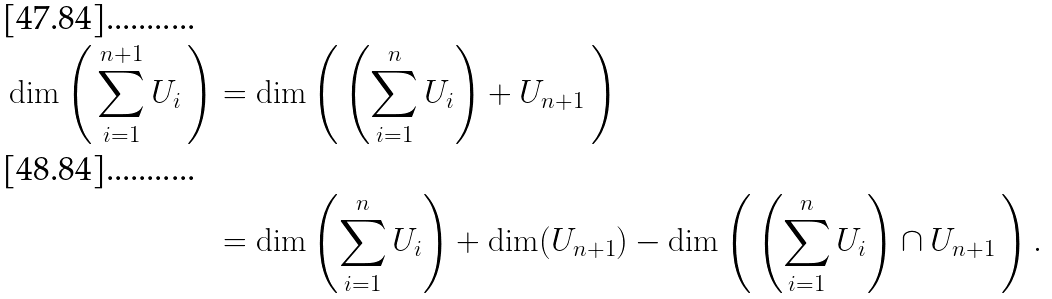Convert formula to latex. <formula><loc_0><loc_0><loc_500><loc_500>\dim \left ( \, \sum _ { i = 1 } ^ { n + 1 } U _ { i } \, \right ) & = \dim \left ( \, \left ( \sum _ { i = 1 } ^ { n } U _ { i } \right ) + U _ { n + 1 } \, \right ) \\ & = \dim \left ( \sum _ { i = 1 } ^ { n } U _ { i } \right ) + \dim ( U _ { n + 1 } ) - \dim \left ( \, \left ( \sum _ { i = 1 } ^ { n } U _ { i } \right ) \cap U _ { n + 1 } \, \right ) .</formula> 